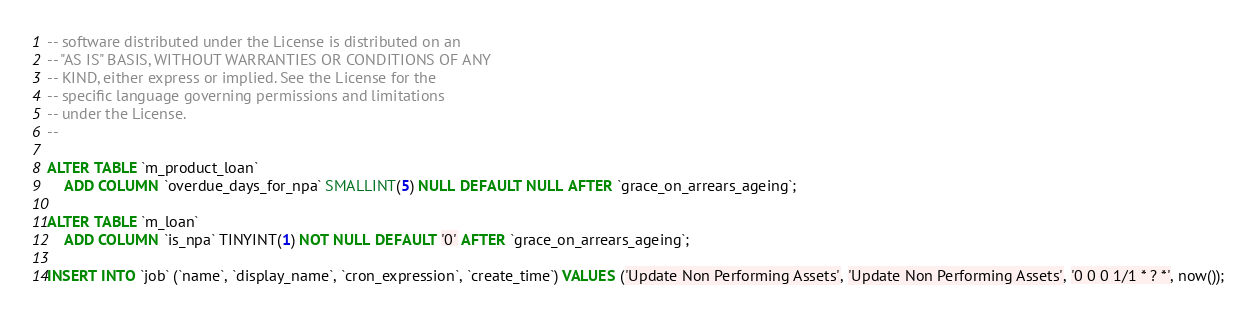<code> <loc_0><loc_0><loc_500><loc_500><_SQL_>-- software distributed under the License is distributed on an
-- "AS IS" BASIS, WITHOUT WARRANTIES OR CONDITIONS OF ANY
-- KIND, either express or implied. See the License for the
-- specific language governing permissions and limitations
-- under the License.
--

ALTER TABLE `m_product_loan`
	ADD COLUMN `overdue_days_for_npa` SMALLINT(5) NULL DEFAULT NULL AFTER `grace_on_arrears_ageing`;

ALTER TABLE `m_loan`
	ADD COLUMN `is_npa` TINYINT(1) NOT NULL DEFAULT '0' AFTER `grace_on_arrears_ageing`;

INSERT INTO `job` (`name`, `display_name`, `cron_expression`, `create_time`) VALUES ('Update Non Performing Assets', 'Update Non Performing Assets', '0 0 0 1/1 * ? *', now());</code> 